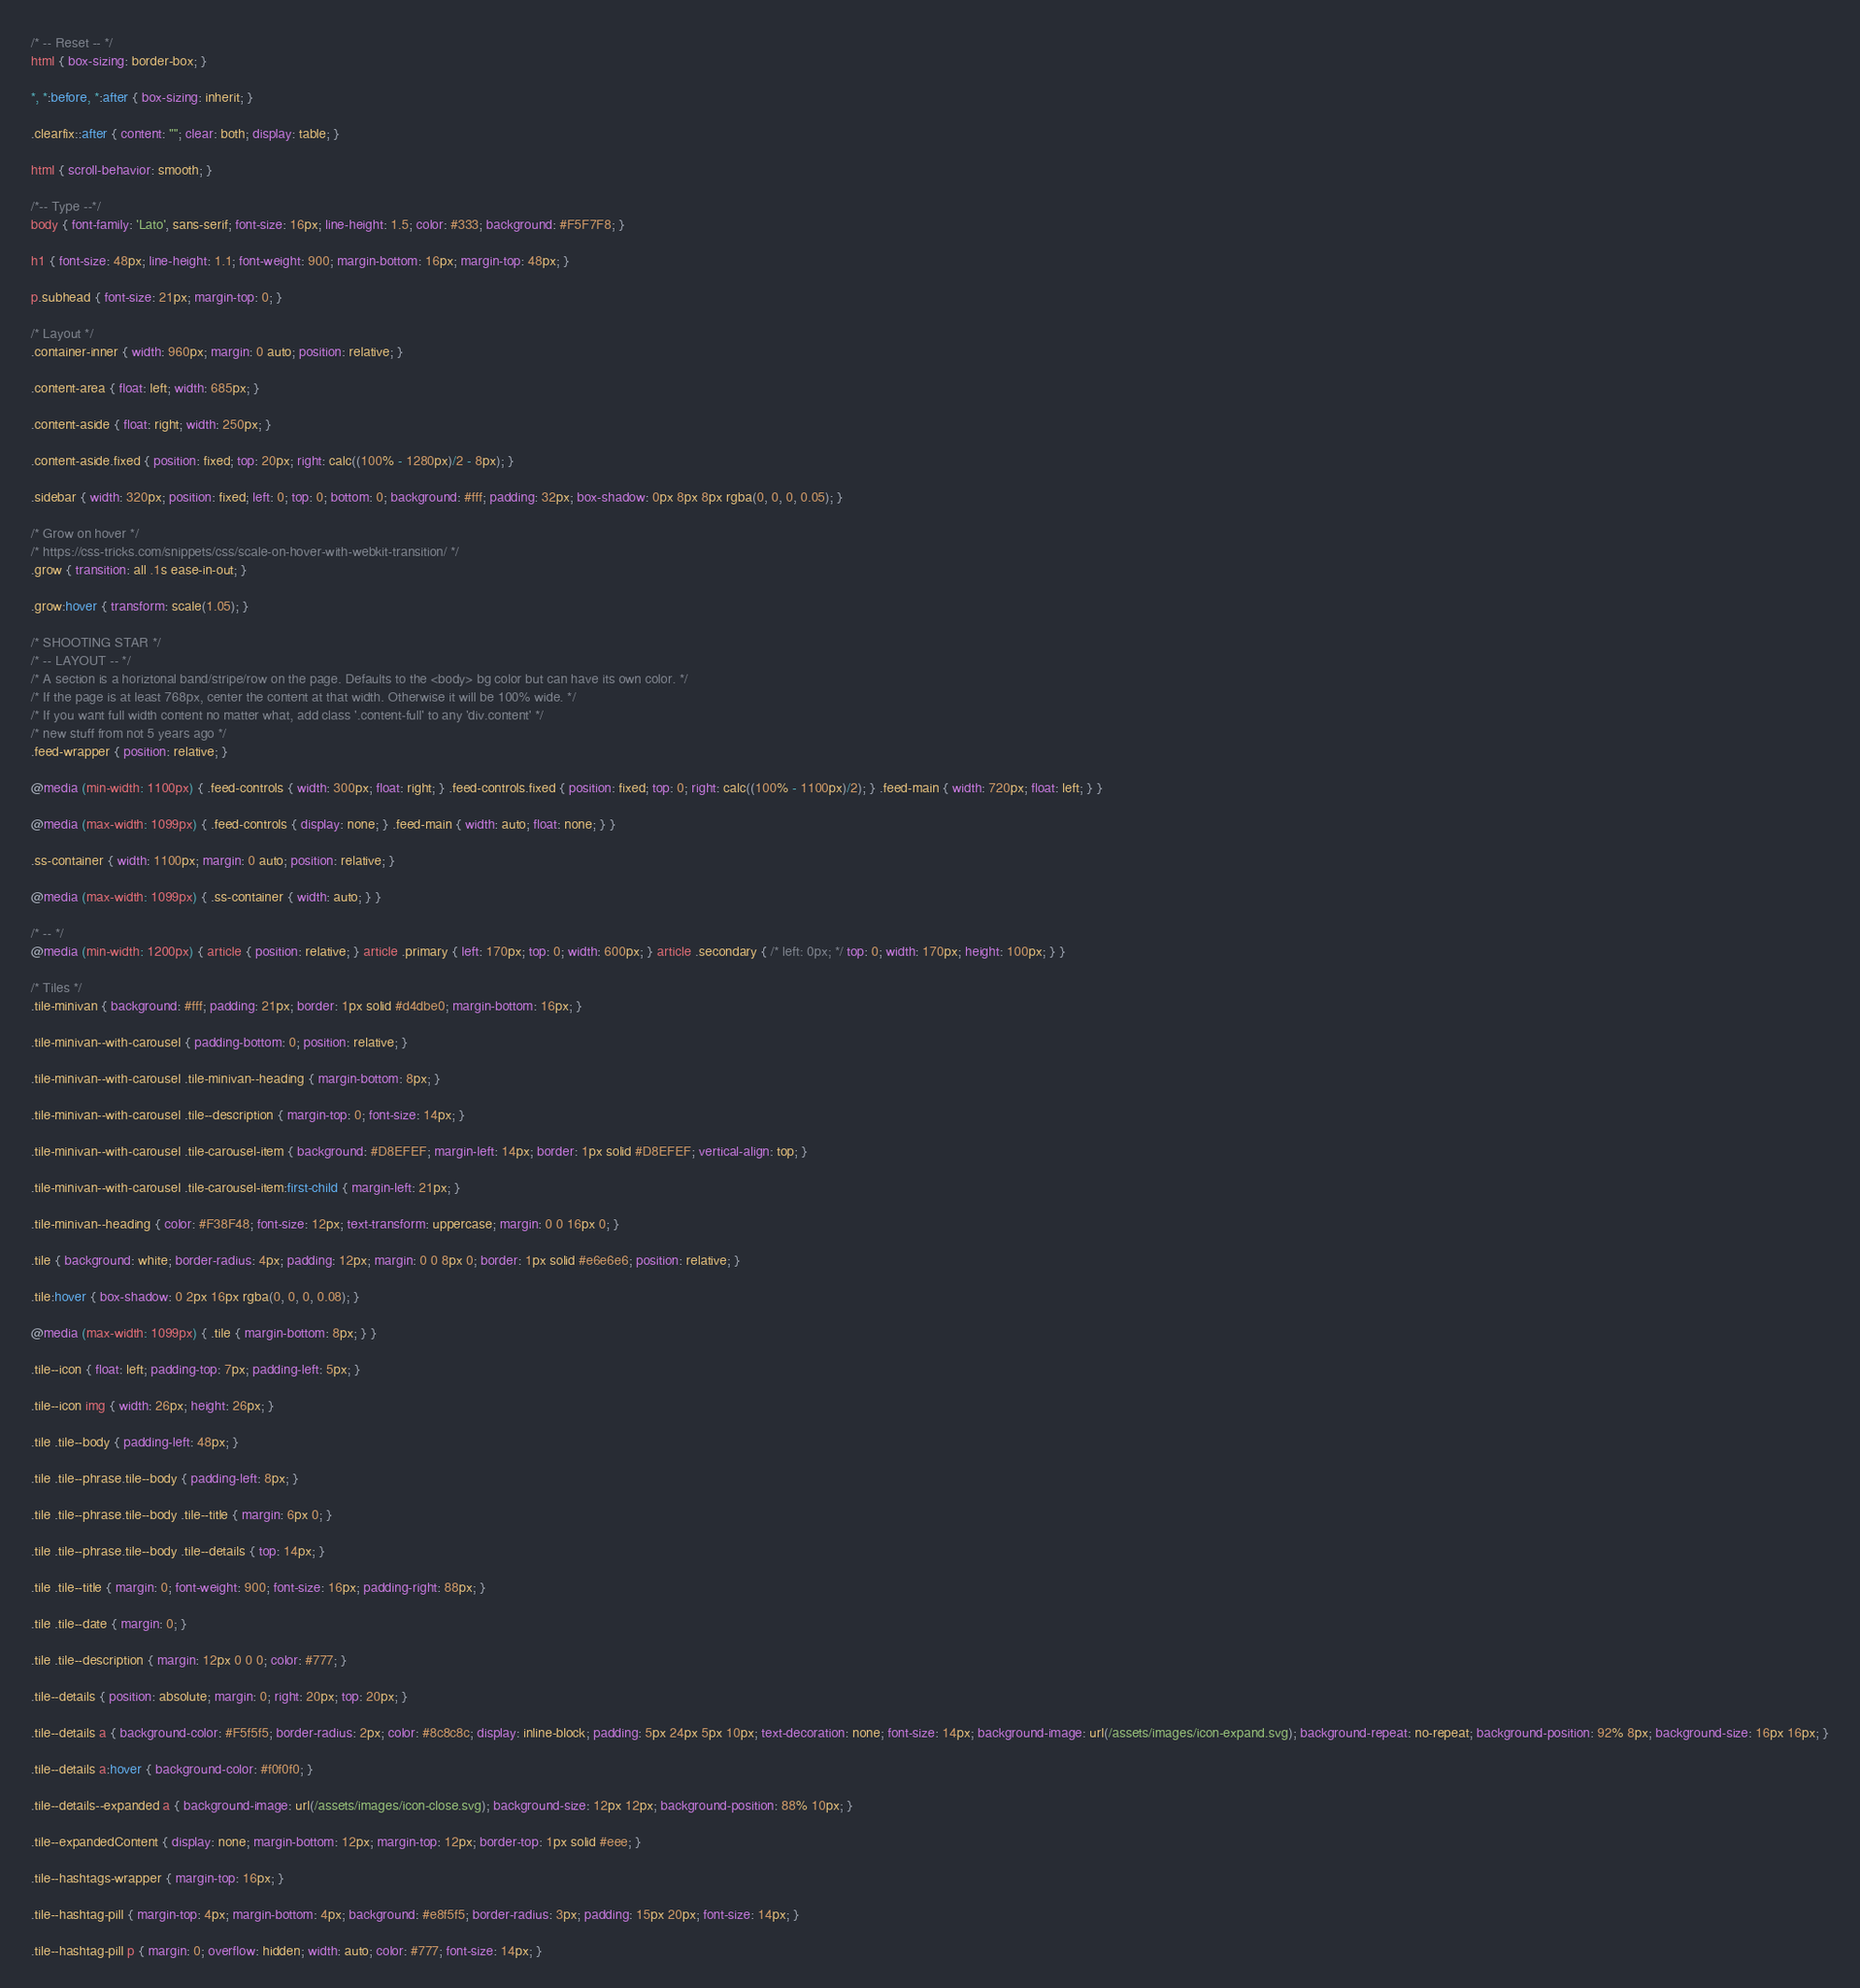<code> <loc_0><loc_0><loc_500><loc_500><_CSS_>/* -- Reset -- */
html { box-sizing: border-box; }

*, *:before, *:after { box-sizing: inherit; }

.clearfix::after { content: ""; clear: both; display: table; }

html { scroll-behavior: smooth; }

/*-- Type --*/
body { font-family: 'Lato', sans-serif; font-size: 16px; line-height: 1.5; color: #333; background: #F5F7F8; }

h1 { font-size: 48px; line-height: 1.1; font-weight: 900; margin-bottom: 16px; margin-top: 48px; }

p.subhead { font-size: 21px; margin-top: 0; }

/* Layout */
.container-inner { width: 960px; margin: 0 auto; position: relative; }

.content-area { float: left; width: 685px; }

.content-aside { float: right; width: 250px; }

.content-aside.fixed { position: fixed; top: 20px; right: calc((100% - 1280px)/2 - 8px); }

.sidebar { width: 320px; position: fixed; left: 0; top: 0; bottom: 0; background: #fff; padding: 32px; box-shadow: 0px 8px 8px rgba(0, 0, 0, 0.05); }

/* Grow on hover */
/* https://css-tricks.com/snippets/css/scale-on-hover-with-webkit-transition/ */
.grow { transition: all .1s ease-in-out; }

.grow:hover { transform: scale(1.05); }

/* SHOOTING STAR */
/* -- LAYOUT -- */
/* A section is a horiztonal band/stripe/row on the page. Defaults to the <body> bg color but can have its own color. */
/* If the page is at least 768px, center the content at that width. Otherwise it will be 100% wide. */
/* If you want full width content no matter what, add class '.content-full' to any 'div.content' */
/* new stuff from not 5 years ago */
.feed-wrapper { position: relative; }

@media (min-width: 1100px) { .feed-controls { width: 300px; float: right; } .feed-controls.fixed { position: fixed; top: 0; right: calc((100% - 1100px)/2); } .feed-main { width: 720px; float: left; } }

@media (max-width: 1099px) { .feed-controls { display: none; } .feed-main { width: auto; float: none; } }

.ss-container { width: 1100px; margin: 0 auto; position: relative; }

@media (max-width: 1099px) { .ss-container { width: auto; } }

/* -- */
@media (min-width: 1200px) { article { position: relative; } article .primary { left: 170px; top: 0; width: 600px; } article .secondary { /* left: 0px; */ top: 0; width: 170px; height: 100px; } }

/* Tiles */
.tile-minivan { background: #fff; padding: 21px; border: 1px solid #d4dbe0; margin-bottom: 16px; }

.tile-minivan--with-carousel { padding-bottom: 0; position: relative; }

.tile-minivan--with-carousel .tile-minivan--heading { margin-bottom: 8px; }

.tile-minivan--with-carousel .tile--description { margin-top: 0; font-size: 14px; }

.tile-minivan--with-carousel .tile-carousel-item { background: #D8EFEF; margin-left: 14px; border: 1px solid #D8EFEF; vertical-align: top; }

.tile-minivan--with-carousel .tile-carousel-item:first-child { margin-left: 21px; }

.tile-minivan--heading { color: #F38F48; font-size: 12px; text-transform: uppercase; margin: 0 0 16px 0; }

.tile { background: white; border-radius: 4px; padding: 12px; margin: 0 0 8px 0; border: 1px solid #e6e6e6; position: relative; }

.tile:hover { box-shadow: 0 2px 16px rgba(0, 0, 0, 0.08); }

@media (max-width: 1099px) { .tile { margin-bottom: 8px; } }

.tile--icon { float: left; padding-top: 7px; padding-left: 5px; }

.tile--icon img { width: 26px; height: 26px; }

.tile .tile--body { padding-left: 48px; }

.tile .tile--phrase.tile--body { padding-left: 8px; }

.tile .tile--phrase.tile--body .tile--title { margin: 6px 0; }

.tile .tile--phrase.tile--body .tile--details { top: 14px; }

.tile .tile--title { margin: 0; font-weight: 900; font-size: 16px; padding-right: 88px; }

.tile .tile--date { margin: 0; }

.tile .tile--description { margin: 12px 0 0 0; color: #777; }

.tile--details { position: absolute; margin: 0; right: 20px; top: 20px; }

.tile--details a { background-color: #F5f5f5; border-radius: 2px; color: #8c8c8c; display: inline-block; padding: 5px 24px 5px 10px; text-decoration: none; font-size: 14px; background-image: url(/assets/images/icon-expand.svg); background-repeat: no-repeat; background-position: 92% 8px; background-size: 16px 16px; }

.tile--details a:hover { background-color: #f0f0f0; }

.tile--details--expanded a { background-image: url(/assets/images/icon-close.svg); background-size: 12px 12px; background-position: 88% 10px; }

.tile--expandedContent { display: none; margin-bottom: 12px; margin-top: 12px; border-top: 1px solid #eee; }

.tile--hashtags-wrapper { margin-top: 16px; }

.tile--hashtag-pill { margin-top: 4px; margin-bottom: 4px; background: #e8f5f5; border-radius: 3px; padding: 15px 20px; font-size: 14px; }

.tile--hashtag-pill p { margin: 0; overflow: hidden; width: auto; color: #777; font-size: 14px; }
</code> 